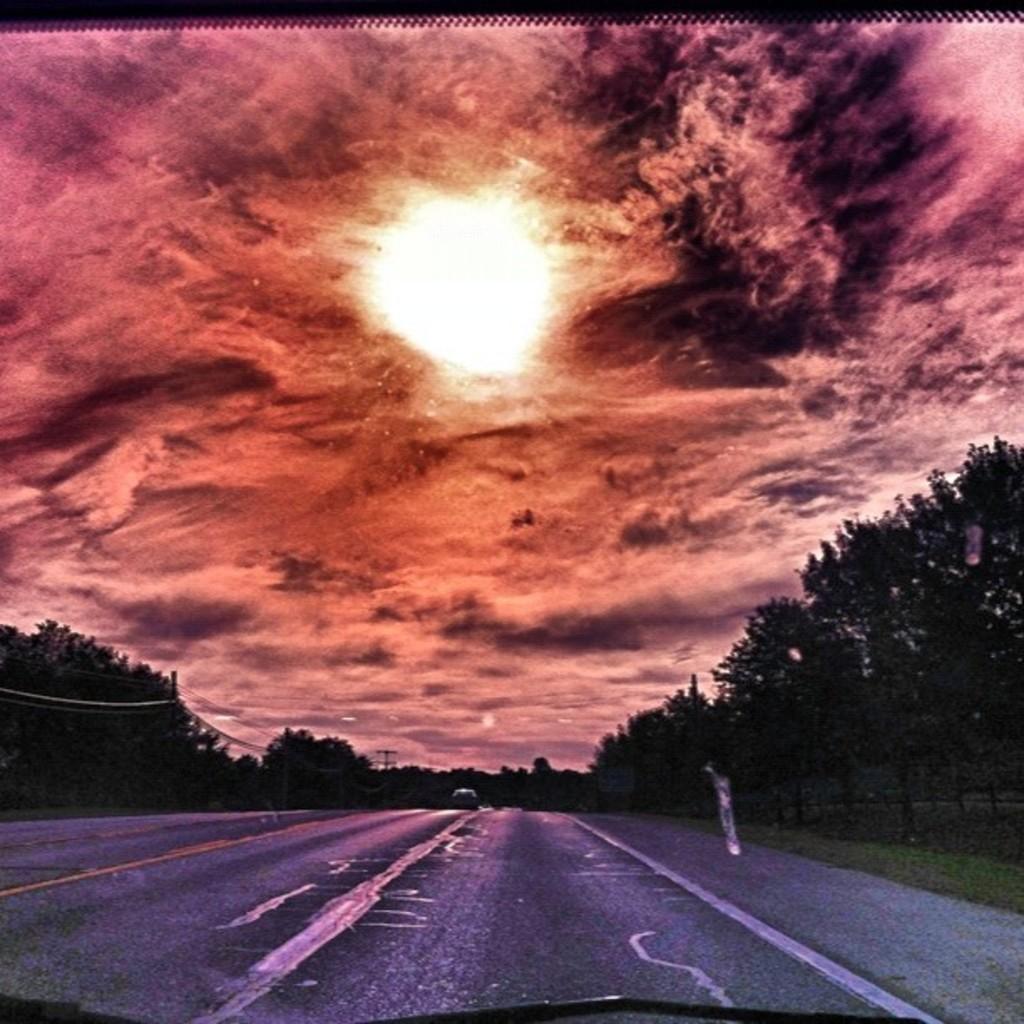Can you describe this image briefly? In front of the image there is some object. There is a car on the road. Beside the road there are electrical poles with cables and trees. There is grass on the surface. At the top of the image there is a sun and clouds in the sky. 